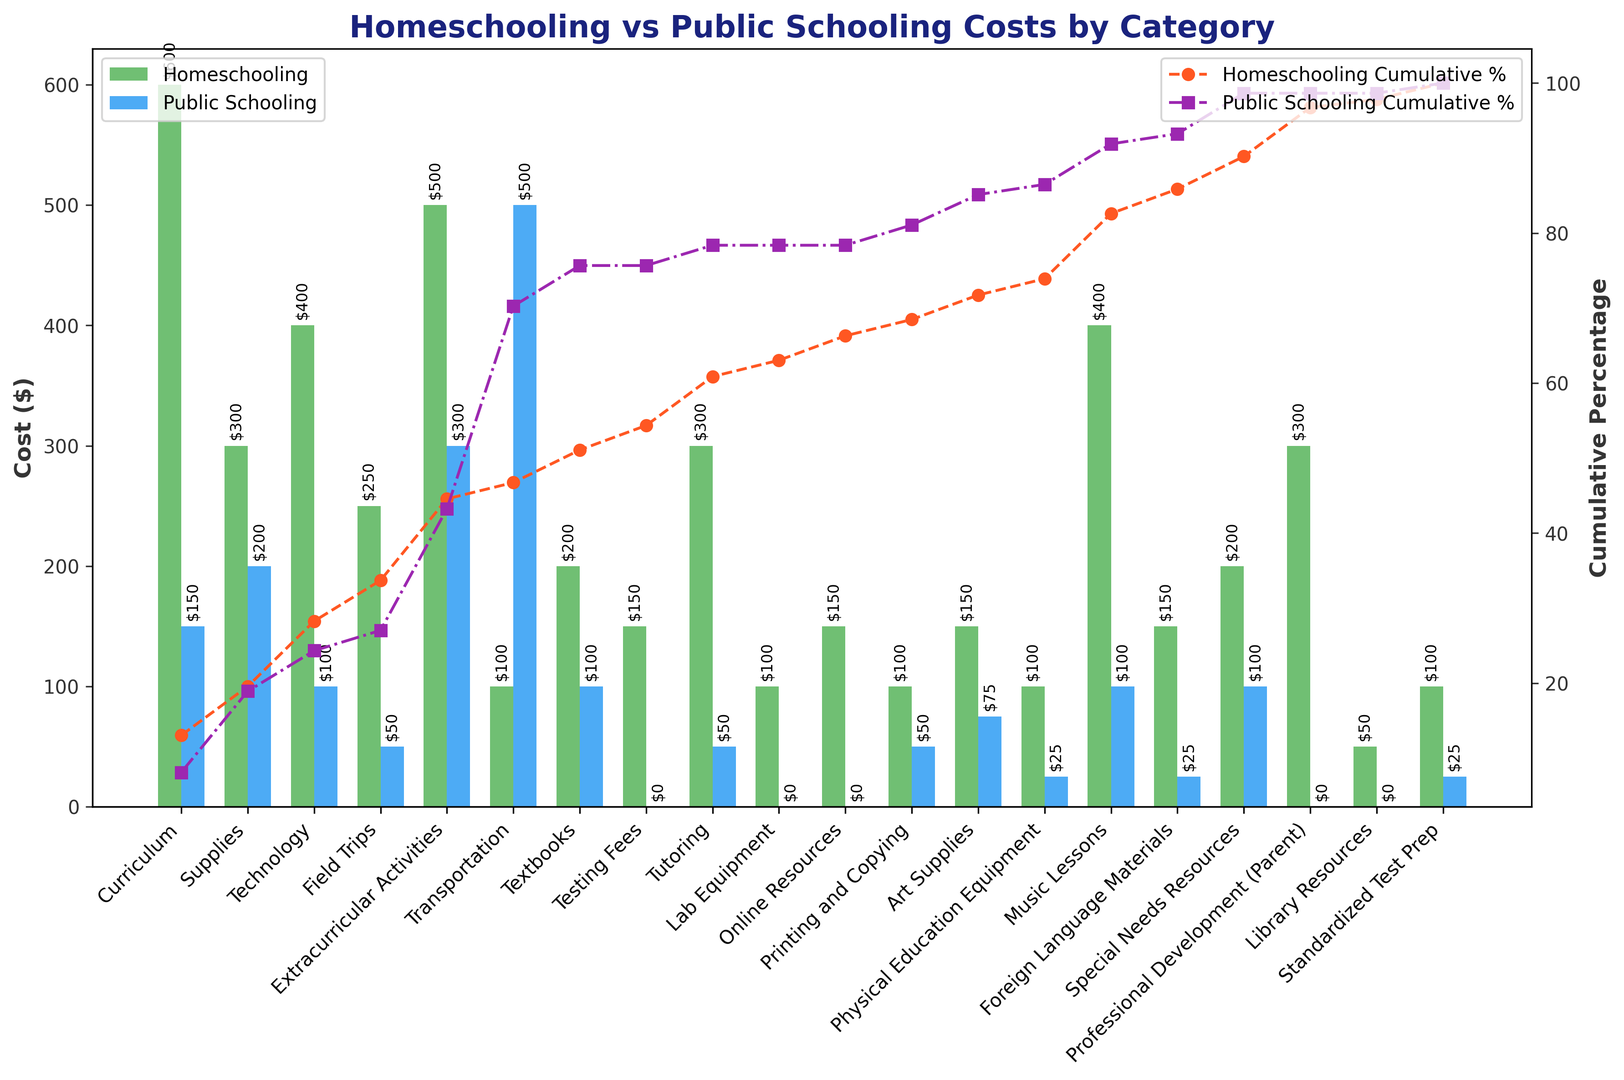Which category has the highest homeschooling cost? Look at the height of the green bars in the chart and check which one is the highest. The tallest green bar corresponds to the category "Curriculum".
Answer: Curriculum What is the total cost difference between homeschooling and public schooling for the "Transportation" category? Calculate the difference by subtracting the Public Schooling Cost ($500) from the Homeschooling Cost ($100) for Transportation. 100 - 500 = -400.
Answer: -$400 How does the cost of "Tutoring" compare between homeschooling and public schooling? Compare the green bar (Homeschooling Cost $300) and the blue bar (Public Schooling Cost $50) for the "Tutoring" category. The green bar is significantly taller, indicating a higher cost for homeschooling.
Answer: Homeschooling is higher What's the cumulative percentage of costs by the fifth category for both homeschooling and public schooling? To find this, refer to the cumulative percentage lines on the secondary Y-axis. Homeschooling (orange line) and Public Schooling (purple line) cumulative percentage can be read at the fifth category (Field Trips). The percentages are approximately 44% for homeschooling and 24% for public schooling.
Answer: Homeschooling: ~44%, Public Schooling: ~24% Which category has the largest cost difference in favor of public schooling? Find the category where the blue bar exceeds the green bar significantly. For "Transportation", Public Schooling ($500) is much higher than Homeschooling ($100), making the difference $400.
Answer: Transportation What are the combined costs of "Art Supplies" for both homeschooling and public schooling? Add the homeschooling cost ($150) and the public schooling cost ($75) for Art Supplies. 150 + 75 = 225.
Answer: $225 Which categories have more than $200 homeschooling costs and less than $50 public schooling costs? Look for categories where the green bar exceeds $200 and the blue bar is below $50. "Field Trips", "Testing Fees", "Lab Equipment", "Online Resources", and "Foreign Language Materials" meet these criteria.
Answer: Field Trips, Testing Fees, Lab Equipment, Online Resources, Foreign Language Materials Is the "Music Lessons" cost higher for homeschooling or public schooling, and by how much? Compare the green bar ($400) to the blue bar ($100) for "Music Lessons". The difference is 400 - 100 = 300.
Answer: Homeschooling by $300 